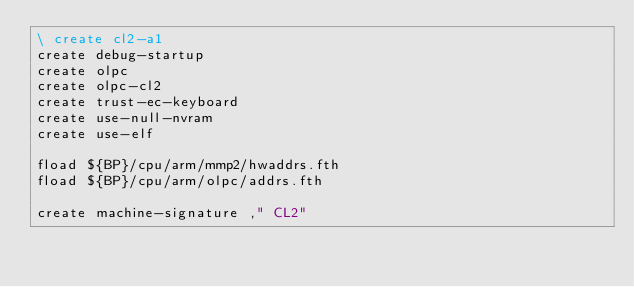Convert code to text. <code><loc_0><loc_0><loc_500><loc_500><_Forth_>\ create cl2-a1
create debug-startup
create olpc
create olpc-cl2
create trust-ec-keyboard
create use-null-nvram
create use-elf

fload ${BP}/cpu/arm/mmp2/hwaddrs.fth
fload ${BP}/cpu/arm/olpc/addrs.fth

create machine-signature ," CL2"
</code> 